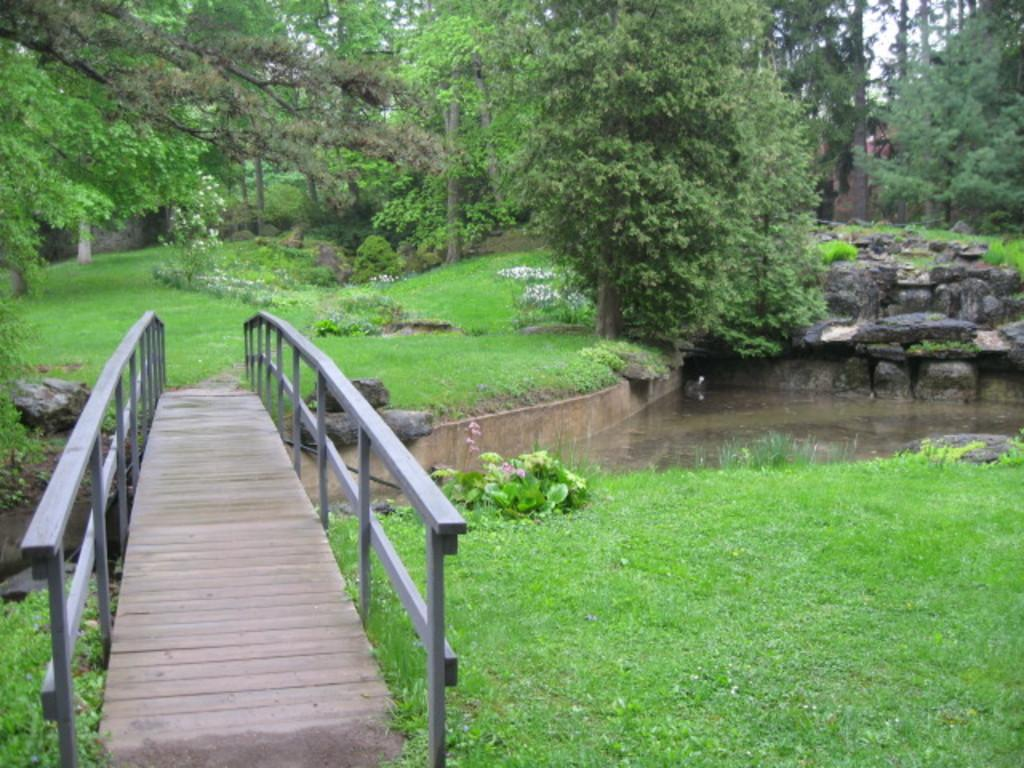What type of structure can be seen in the image? There is a small bridge in the image. What is located on the right side of the image? There is water on the right side of the image. What type of vegetation is present in the image? There are green trees in the image. How many dogs are playing with a snake in the image? There are no dogs or snakes present in the image. 